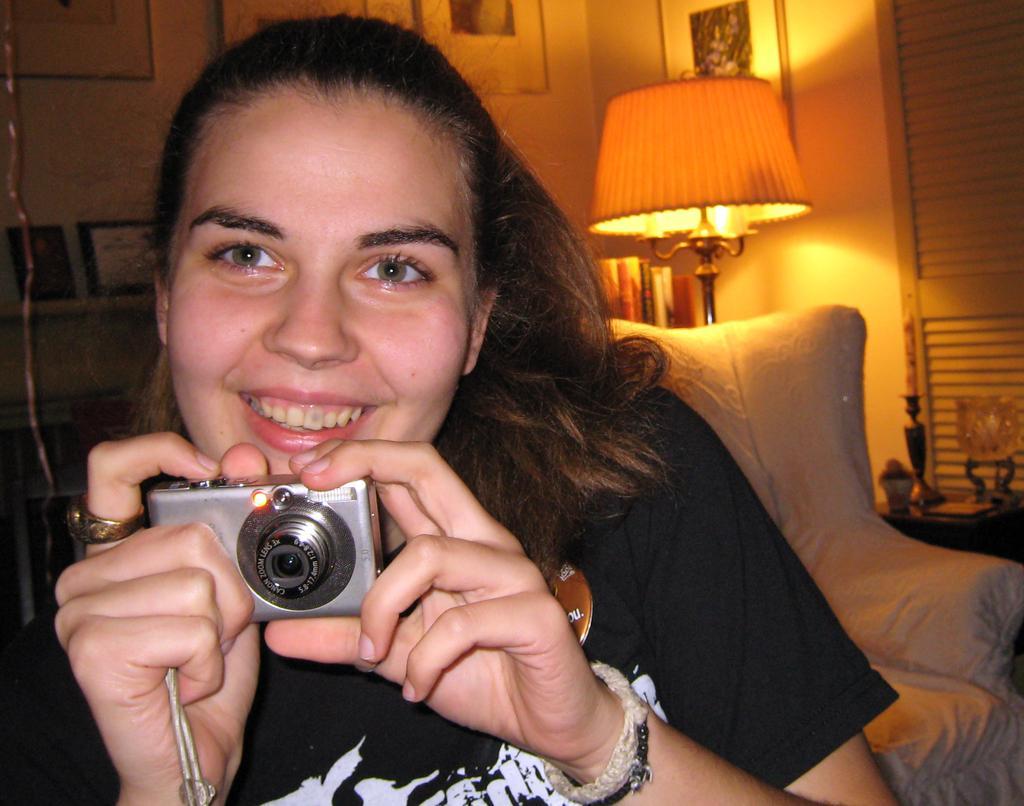Can you describe this image briefly? In this image we can see a woman is holding a camera in her hands. In the background we can see a chair, lamp and objects on a table, frames on the wall and other objects. 